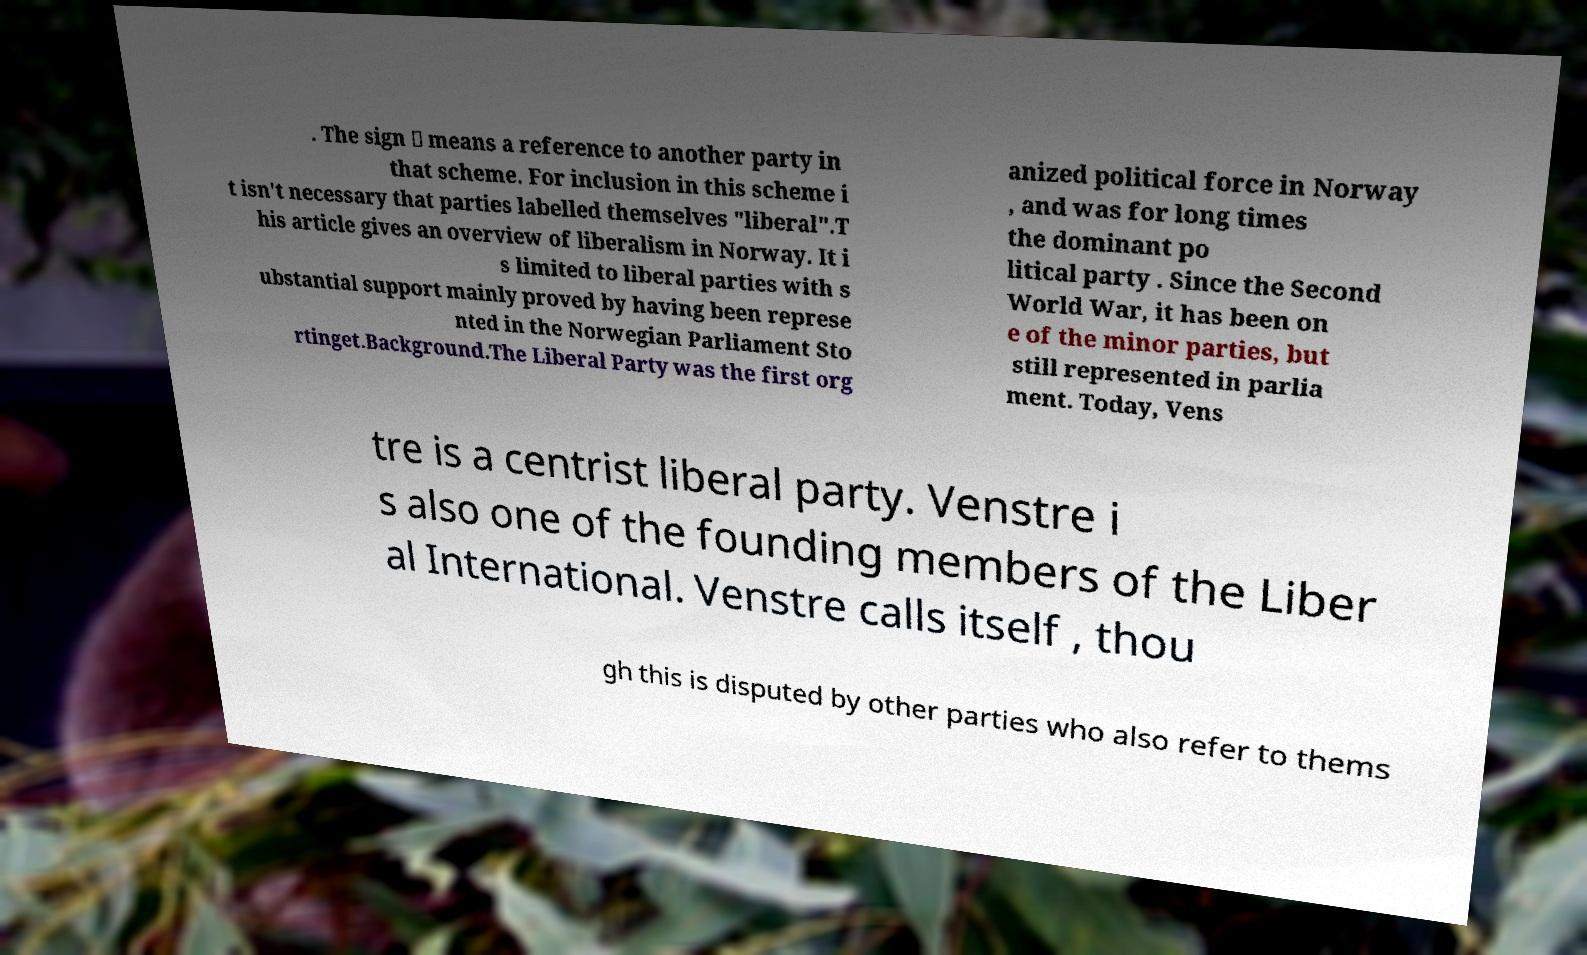Could you extract and type out the text from this image? . The sign ⇒ means a reference to another party in that scheme. For inclusion in this scheme i t isn't necessary that parties labelled themselves "liberal".T his article gives an overview of liberalism in Norway. It i s limited to liberal parties with s ubstantial support mainly proved by having been represe nted in the Norwegian Parliament Sto rtinget.Background.The Liberal Party was the first org anized political force in Norway , and was for long times the dominant po litical party . Since the Second World War, it has been on e of the minor parties, but still represented in parlia ment. Today, Vens tre is a centrist liberal party. Venstre i s also one of the founding members of the Liber al International. Venstre calls itself , thou gh this is disputed by other parties who also refer to thems 